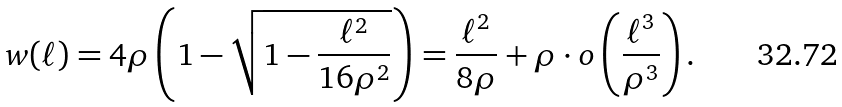Convert formula to latex. <formula><loc_0><loc_0><loc_500><loc_500>w ( \ell ) = 4 \rho \left ( 1 - \sqrt { 1 - \frac { \ell ^ { 2 } } { 1 6 \rho ^ { 2 } } } \right ) = \frac { \ell ^ { 2 } } { 8 \rho } + \rho \cdot o \left ( \frac { \ell ^ { 3 } } { \rho ^ { 3 } } \right ) .</formula> 